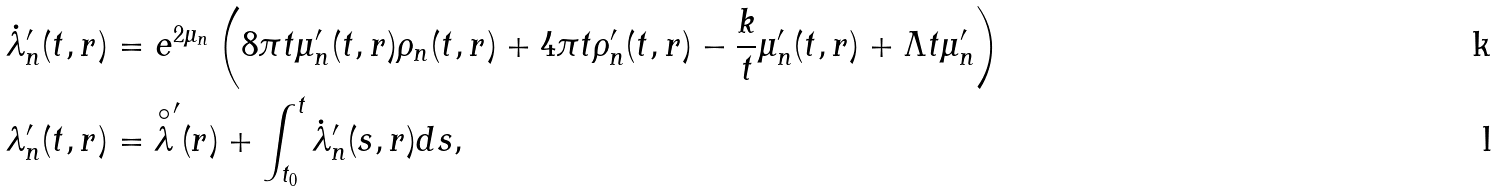Convert formula to latex. <formula><loc_0><loc_0><loc_500><loc_500>\dot { \lambda } _ { n } ^ { \prime } ( t , r ) & = e ^ { 2 \mu _ { n } } \left ( 8 \pi t \mu _ { n } ^ { \prime } ( t , r ) \rho _ { n } ( t , r ) + 4 \pi t \rho _ { n } ^ { \prime } ( t , r ) - \frac { k } { t } \mu _ { n } ^ { \prime } ( t , r ) + \Lambda t \mu _ { n } ^ { \prime } \right ) \\ \lambda _ { n } ^ { \prime } ( t , r ) & = \overset { \circ } { \lambda } ^ { \prime } ( r ) + \int _ { t _ { 0 } } ^ { t } \dot { \lambda } _ { n } ^ { \prime } ( s , r ) d s ,</formula> 